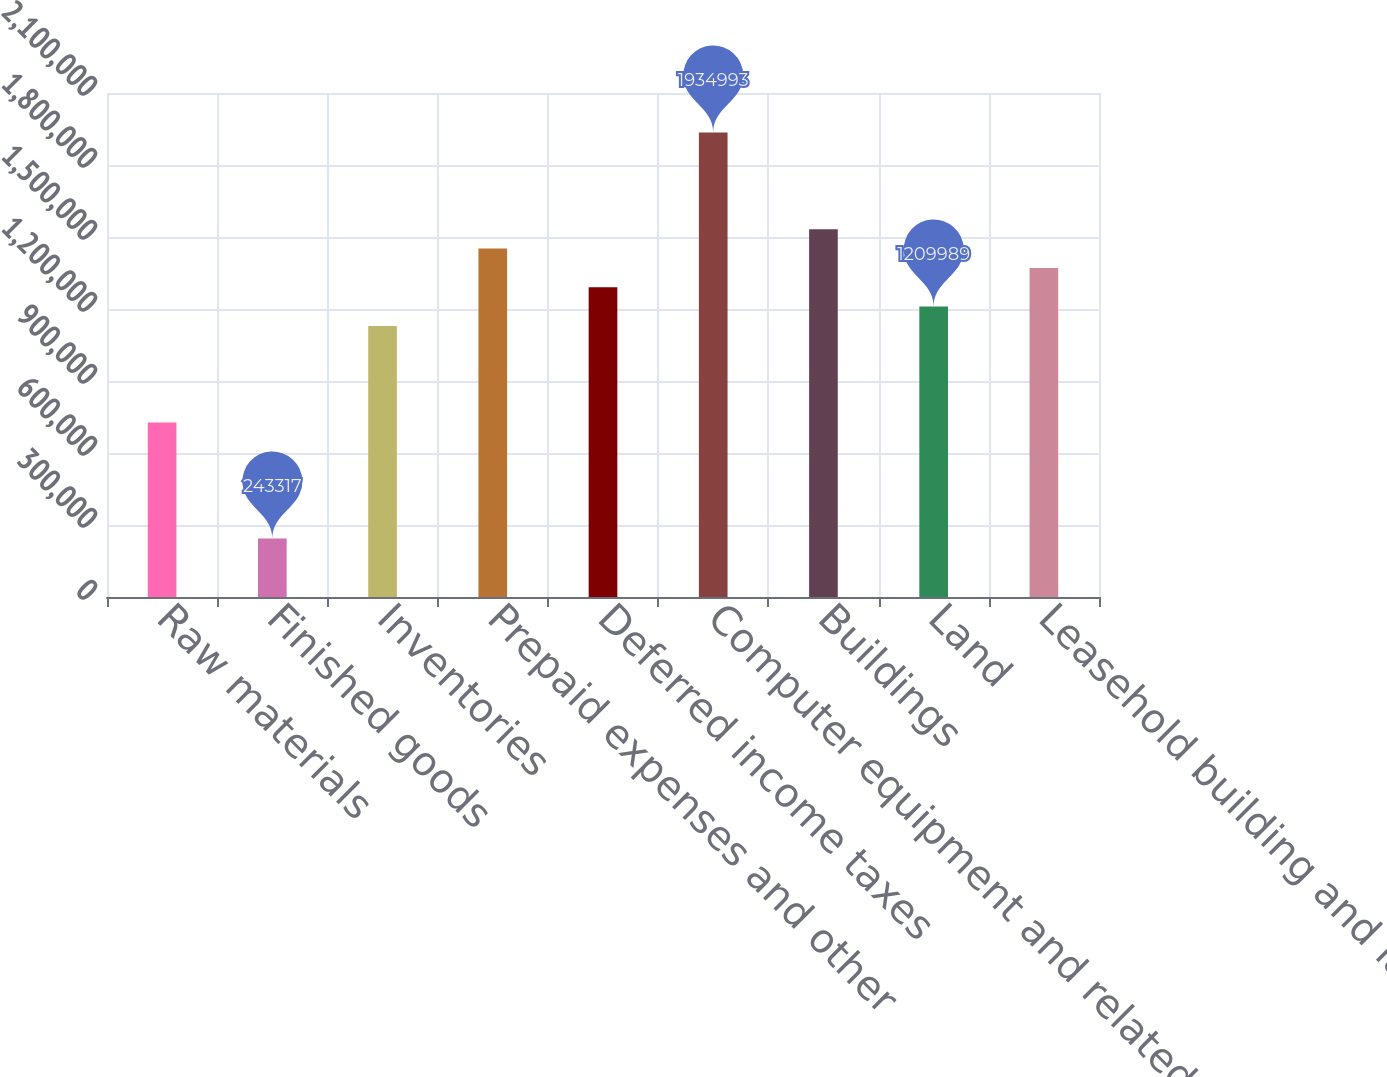Convert chart. <chart><loc_0><loc_0><loc_500><loc_500><bar_chart><fcel>Raw materials<fcel>Finished goods<fcel>Inventories<fcel>Prepaid expenses and other<fcel>Deferred income taxes<fcel>Computer equipment and related<fcel>Buildings<fcel>Land<fcel>Leasehold building and land<nl><fcel>726653<fcel>243317<fcel>1.12943e+06<fcel>1.45166e+06<fcel>1.29054e+06<fcel>1.93499e+06<fcel>1.53221e+06<fcel>1.20999e+06<fcel>1.3711e+06<nl></chart> 